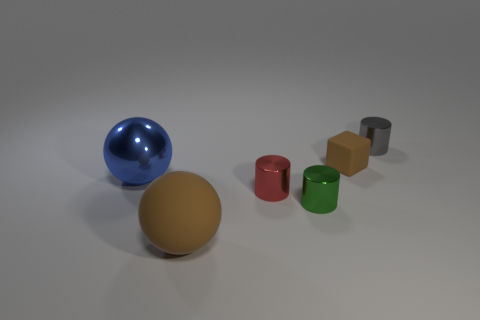What textures are visible in the objects shown? Looking at the image, we can observe different textures: the big sphere has a matte surface, the smaller blue sphere has a reflective surface, and the cylinders seem to have a more satin or semi-gloss finish. 